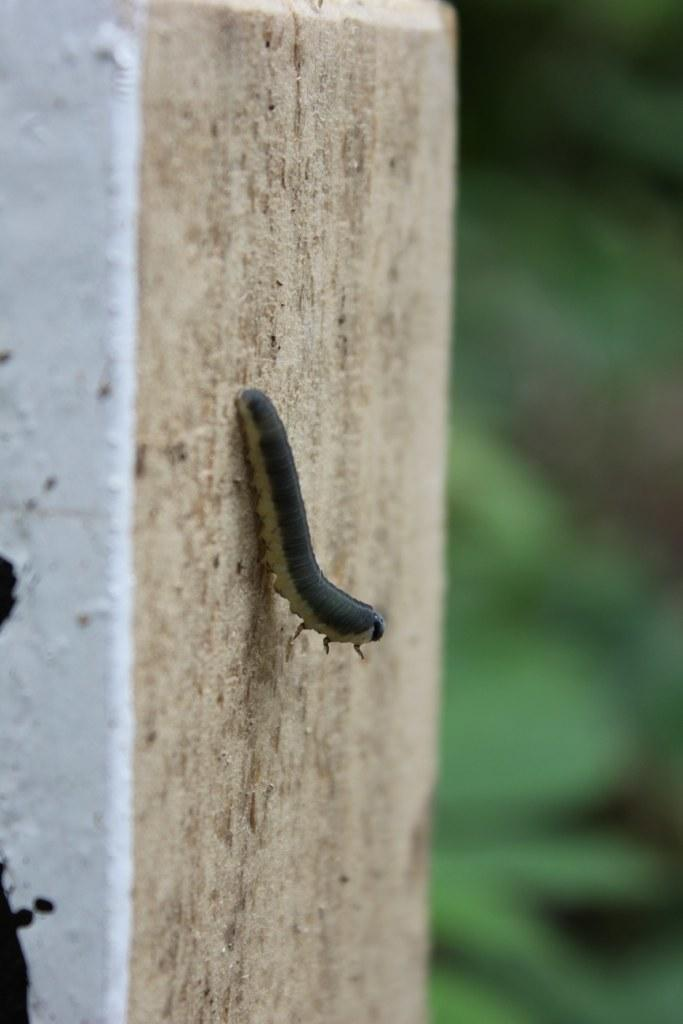What type of creature is present in the image? There is an insect in the image. What color pattern can be observed on an object in the image? There is an object with white and black colors in the image. How would you describe the background on the right side of the image? The background on the right side of the image is blurred. How many legs does the insect have, and how does it participate in the operation? There is no operation present in the image, and the number of legs the insect has cannot be determined from the image alone. 